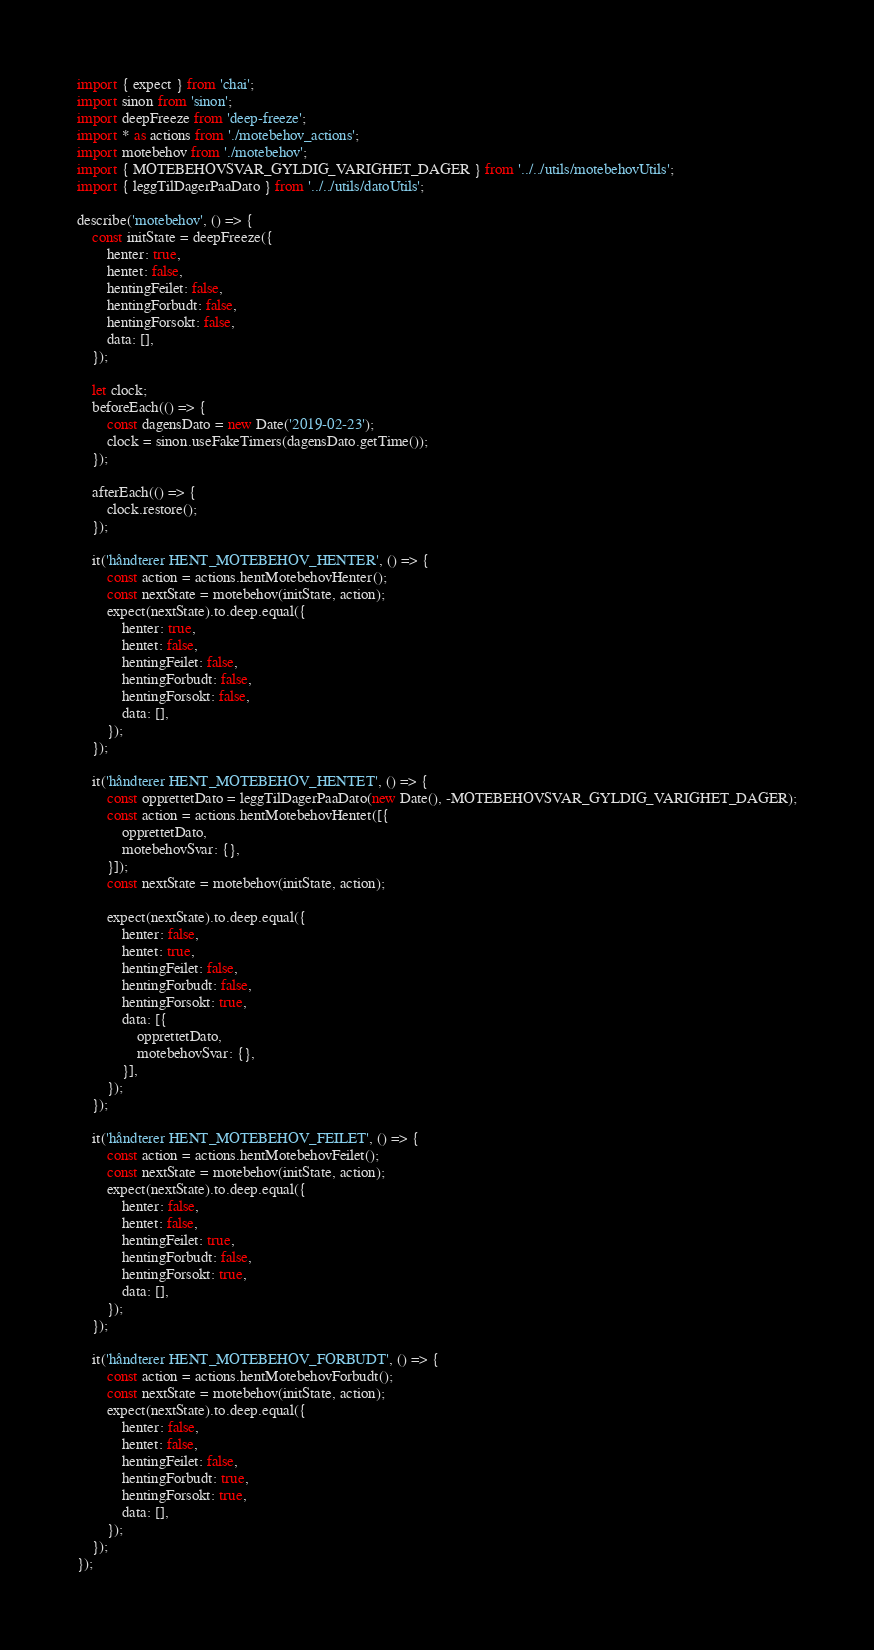<code> <loc_0><loc_0><loc_500><loc_500><_JavaScript_>import { expect } from 'chai';
import sinon from 'sinon';
import deepFreeze from 'deep-freeze';
import * as actions from './motebehov_actions';
import motebehov from './motebehov';
import { MOTEBEHOVSVAR_GYLDIG_VARIGHET_DAGER } from '../../utils/motebehovUtils';
import { leggTilDagerPaaDato } from '../../utils/datoUtils';

describe('motebehov', () => {
    const initState = deepFreeze({
        henter: true,
        hentet: false,
        hentingFeilet: false,
        hentingForbudt: false,
        hentingForsokt: false,
        data: [],
    });

    let clock;
    beforeEach(() => {
        const dagensDato = new Date('2019-02-23');
        clock = sinon.useFakeTimers(dagensDato.getTime());
    });

    afterEach(() => {
        clock.restore();
    });

    it('håndterer HENT_MOTEBEHOV_HENTER', () => {
        const action = actions.hentMotebehovHenter();
        const nextState = motebehov(initState, action);
        expect(nextState).to.deep.equal({
            henter: true,
            hentet: false,
            hentingFeilet: false,
            hentingForbudt: false,
            hentingForsokt: false,
            data: [],
        });
    });

    it('håndterer HENT_MOTEBEHOV_HENTET', () => {
        const opprettetDato = leggTilDagerPaaDato(new Date(), -MOTEBEHOVSVAR_GYLDIG_VARIGHET_DAGER);
        const action = actions.hentMotebehovHentet([{
            opprettetDato,
            motebehovSvar: {},
        }]);
        const nextState = motebehov(initState, action);

        expect(nextState).to.deep.equal({
            henter: false,
            hentet: true,
            hentingFeilet: false,
            hentingForbudt: false,
            hentingForsokt: true,
            data: [{
                opprettetDato,
                motebehovSvar: {},
            }],
        });
    });

    it('håndterer HENT_MOTEBEHOV_FEILET', () => {
        const action = actions.hentMotebehovFeilet();
        const nextState = motebehov(initState, action);
        expect(nextState).to.deep.equal({
            henter: false,
            hentet: false,
            hentingFeilet: true,
            hentingForbudt: false,
            hentingForsokt: true,
            data: [],
        });
    });

    it('håndterer HENT_MOTEBEHOV_FORBUDT', () => {
        const action = actions.hentMotebehovForbudt();
        const nextState = motebehov(initState, action);
        expect(nextState).to.deep.equal({
            henter: false,
            hentet: false,
            hentingFeilet: false,
            hentingForbudt: true,
            hentingForsokt: true,
            data: [],
        });
    });
});
</code> 